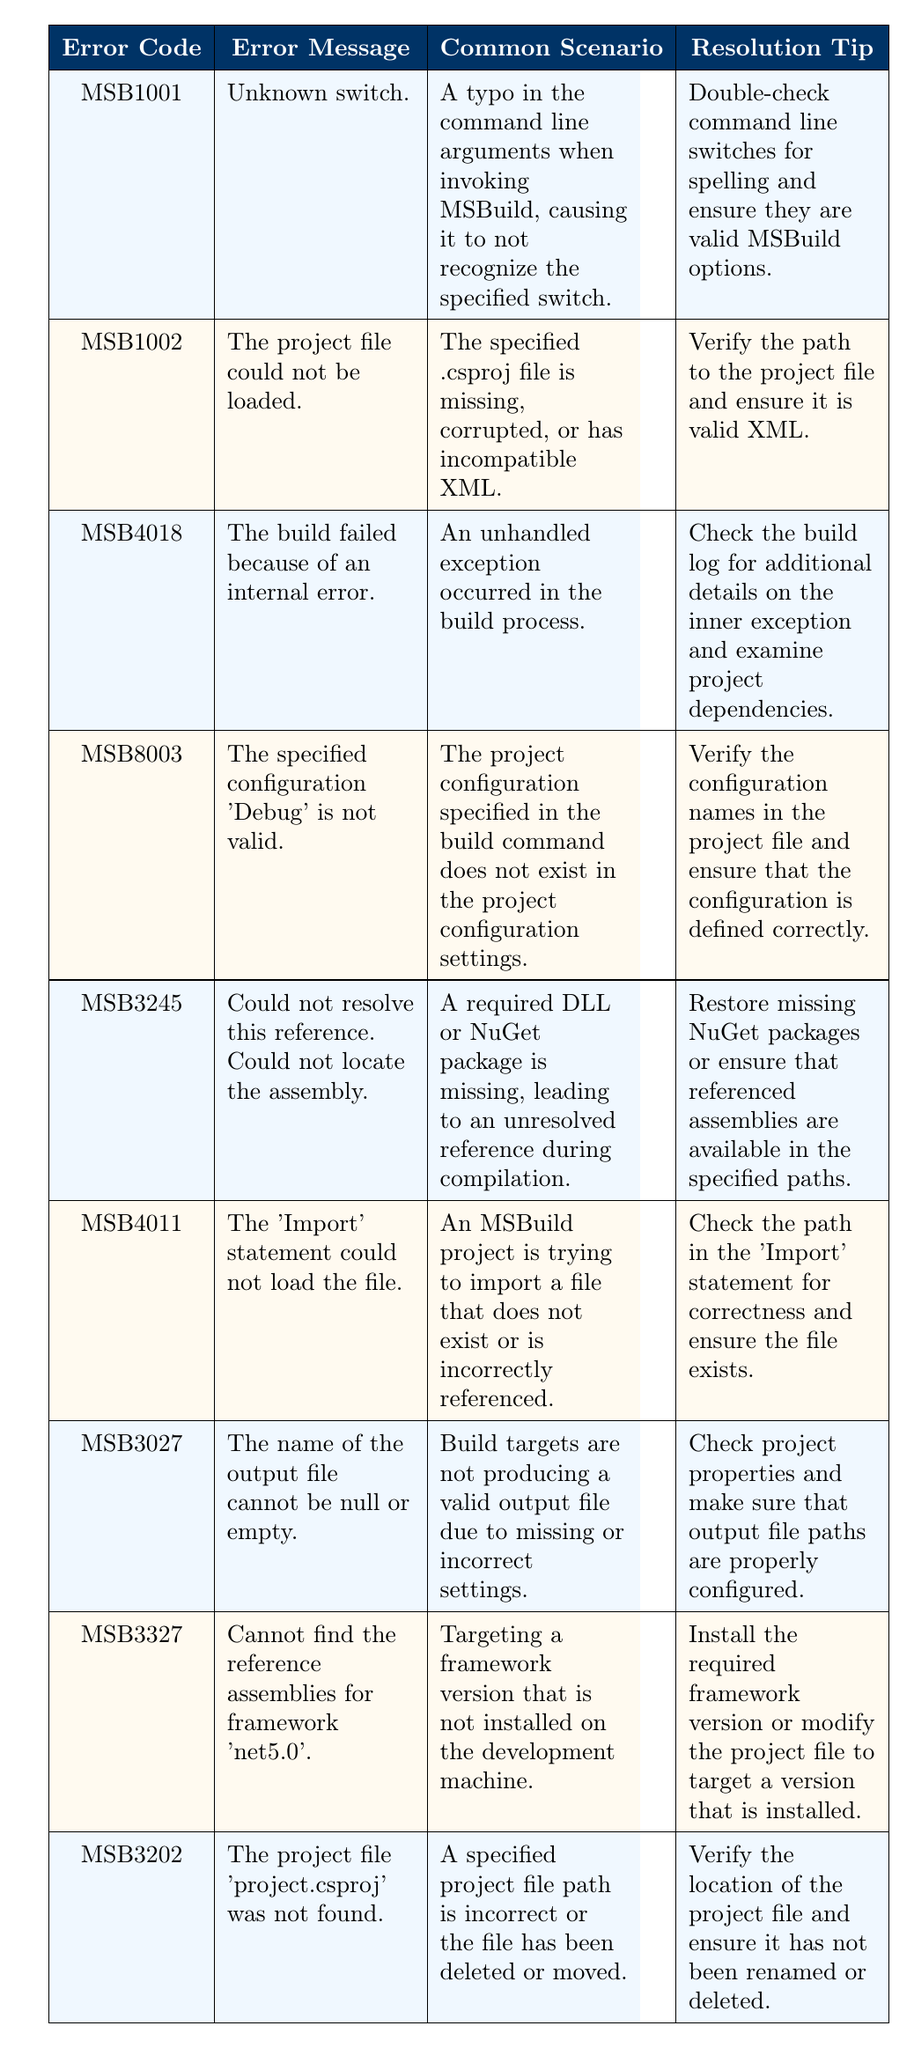What does error code MSB1001 indicate? Error code MSB1001 refers to an "Unknown switch," which typically arises from a typo in the command line arguments used to invoke MSBuild. This means that the command entered does not recognize the specified switch due to a spelling mistake or it not being a valid option in MSBuild.
Answer: Unknown switch What is a common scenario that leads to error code MSB8003? Error code MSB8003 refers to a situation where the specified configuration 'Debug' is not valid. This typically occurs when the project configuration named 'Debug' is not defined in the project's configuration settings. To understand this scenario, one should verify the presence of that configuration in the project file.
Answer: The project configuration 'Debug' is not found Which error indicates a reference assembly is missing? Error code MSB3327, which indicates that reference assemblies for 'net5.0' cannot be found, signals that the project is targeting a framework that is not installed on the machine. This error highlights that a required version of the framework must be either installed or targeted properly in the project file.
Answer: MSB3327 Is it true that error MSB4011 can occur due to an incorrectly referenced file? Yes, this is true. Error code MSB4011 arises when an MSBuild project attempts to import a file that either does not exist or has been incorrectly referenced. Ensuring that the path in the 'Import' statement is correct can resolve this issue.
Answer: Yes How many error codes are associated with project file loading issues? Three error codes are associated with project file loading issues. They are MSB1002 (project file could not be loaded), MSB3202 (project file not found), and MSB4011 (import statement could not load the file). Each of these errors highlights different aspects of problems encountered when loading project files.
Answer: Three 